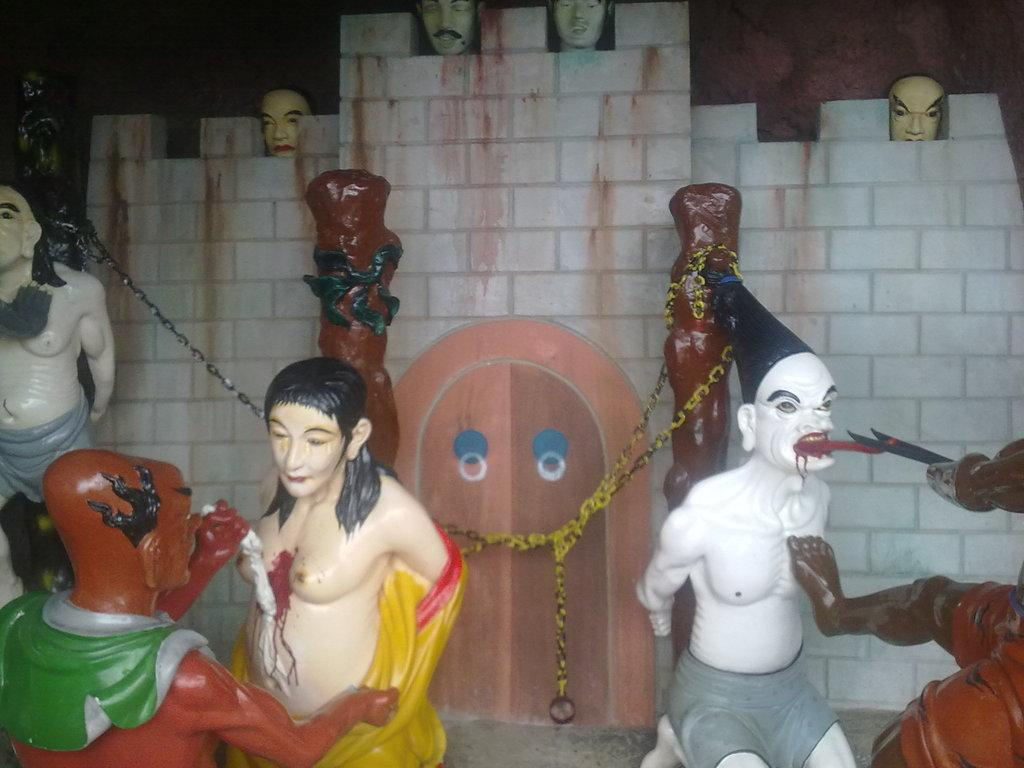What can be seen in the foreground of the image? There are sculptures of persons in the foreground of the image. What is visible in the background of the image? There is a wall, a door, a chain, and persons' faces visible in the background of the image. Can you describe the door in the background? The door is located in the background of the image. How many people are in the crowd in the image? There is no crowd present in the image; it features sculptures of persons in the foreground and various elements in the background. What type of belief system is depicted in the image? There is no specific belief system depicted in the image; it primarily consists of sculptures and background elements. 